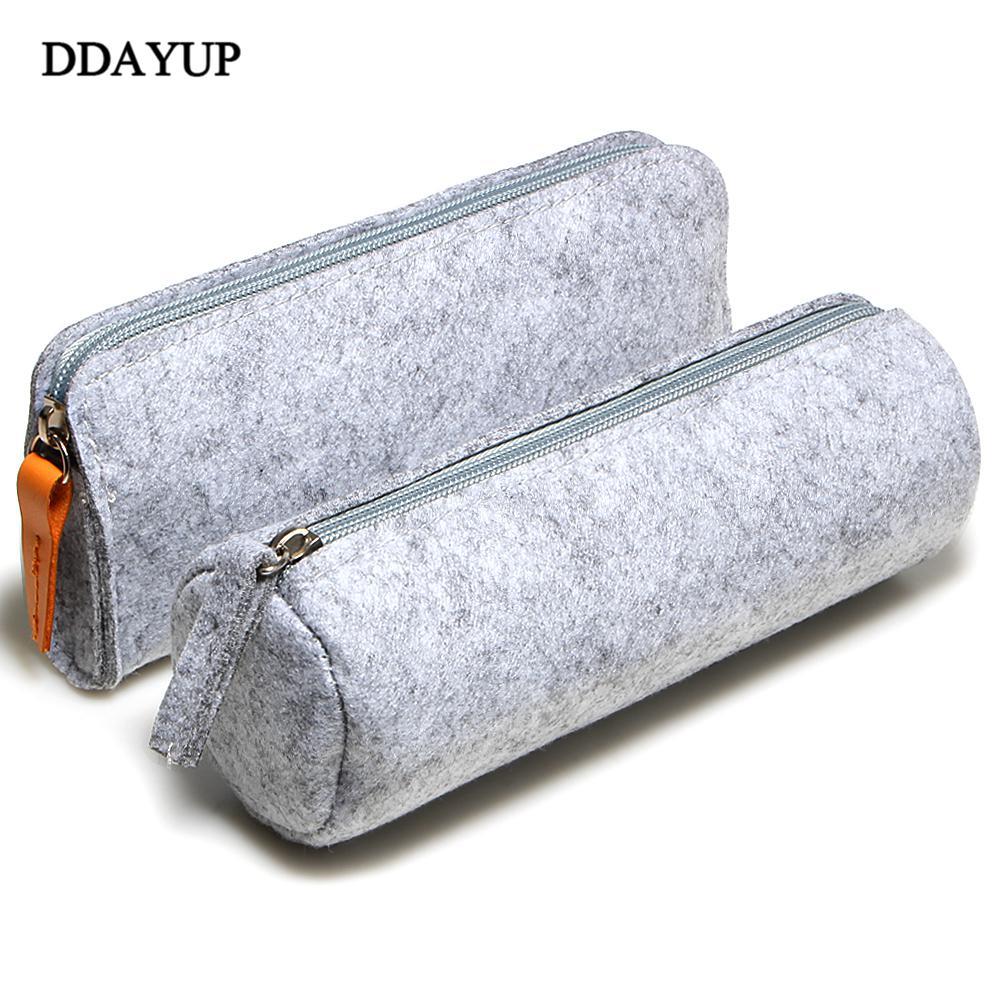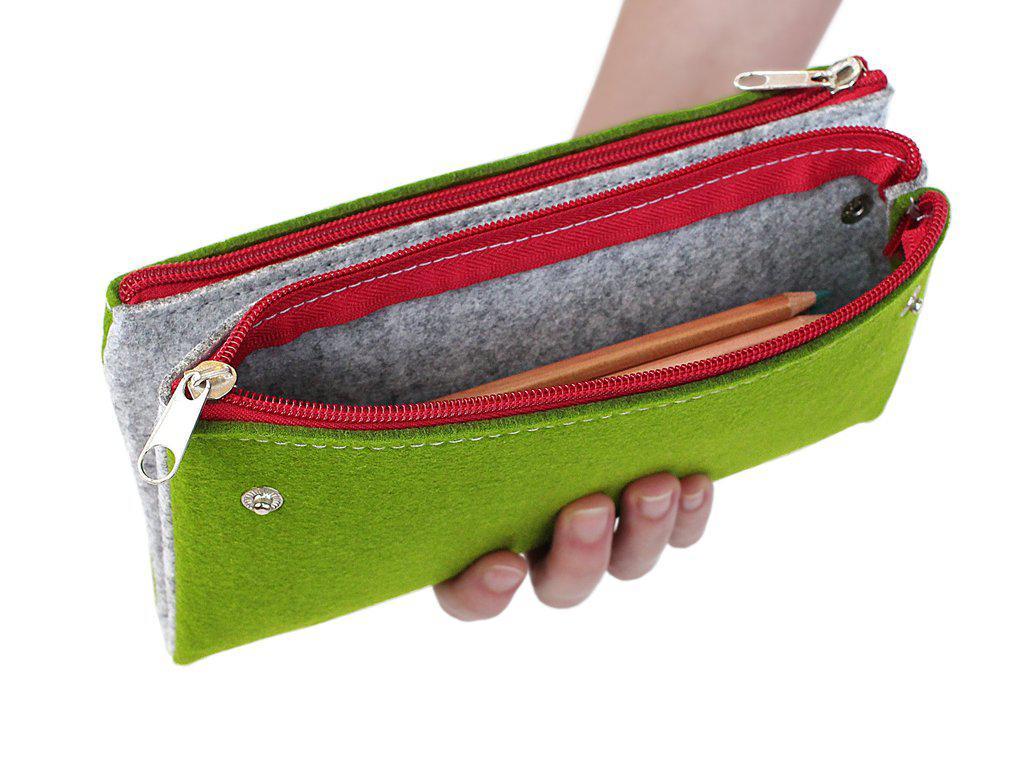The first image is the image on the left, the second image is the image on the right. Analyze the images presented: Is the assertion "The left image contains a gray tube-shaped zipper case to the left of a green one, and the right image includes gray, green and orange closed tube-shaped cases." valid? Answer yes or no. No. The first image is the image on the left, the second image is the image on the right. Analyze the images presented: Is the assertion "There are five or more felt pencil cases." valid? Answer yes or no. No. 